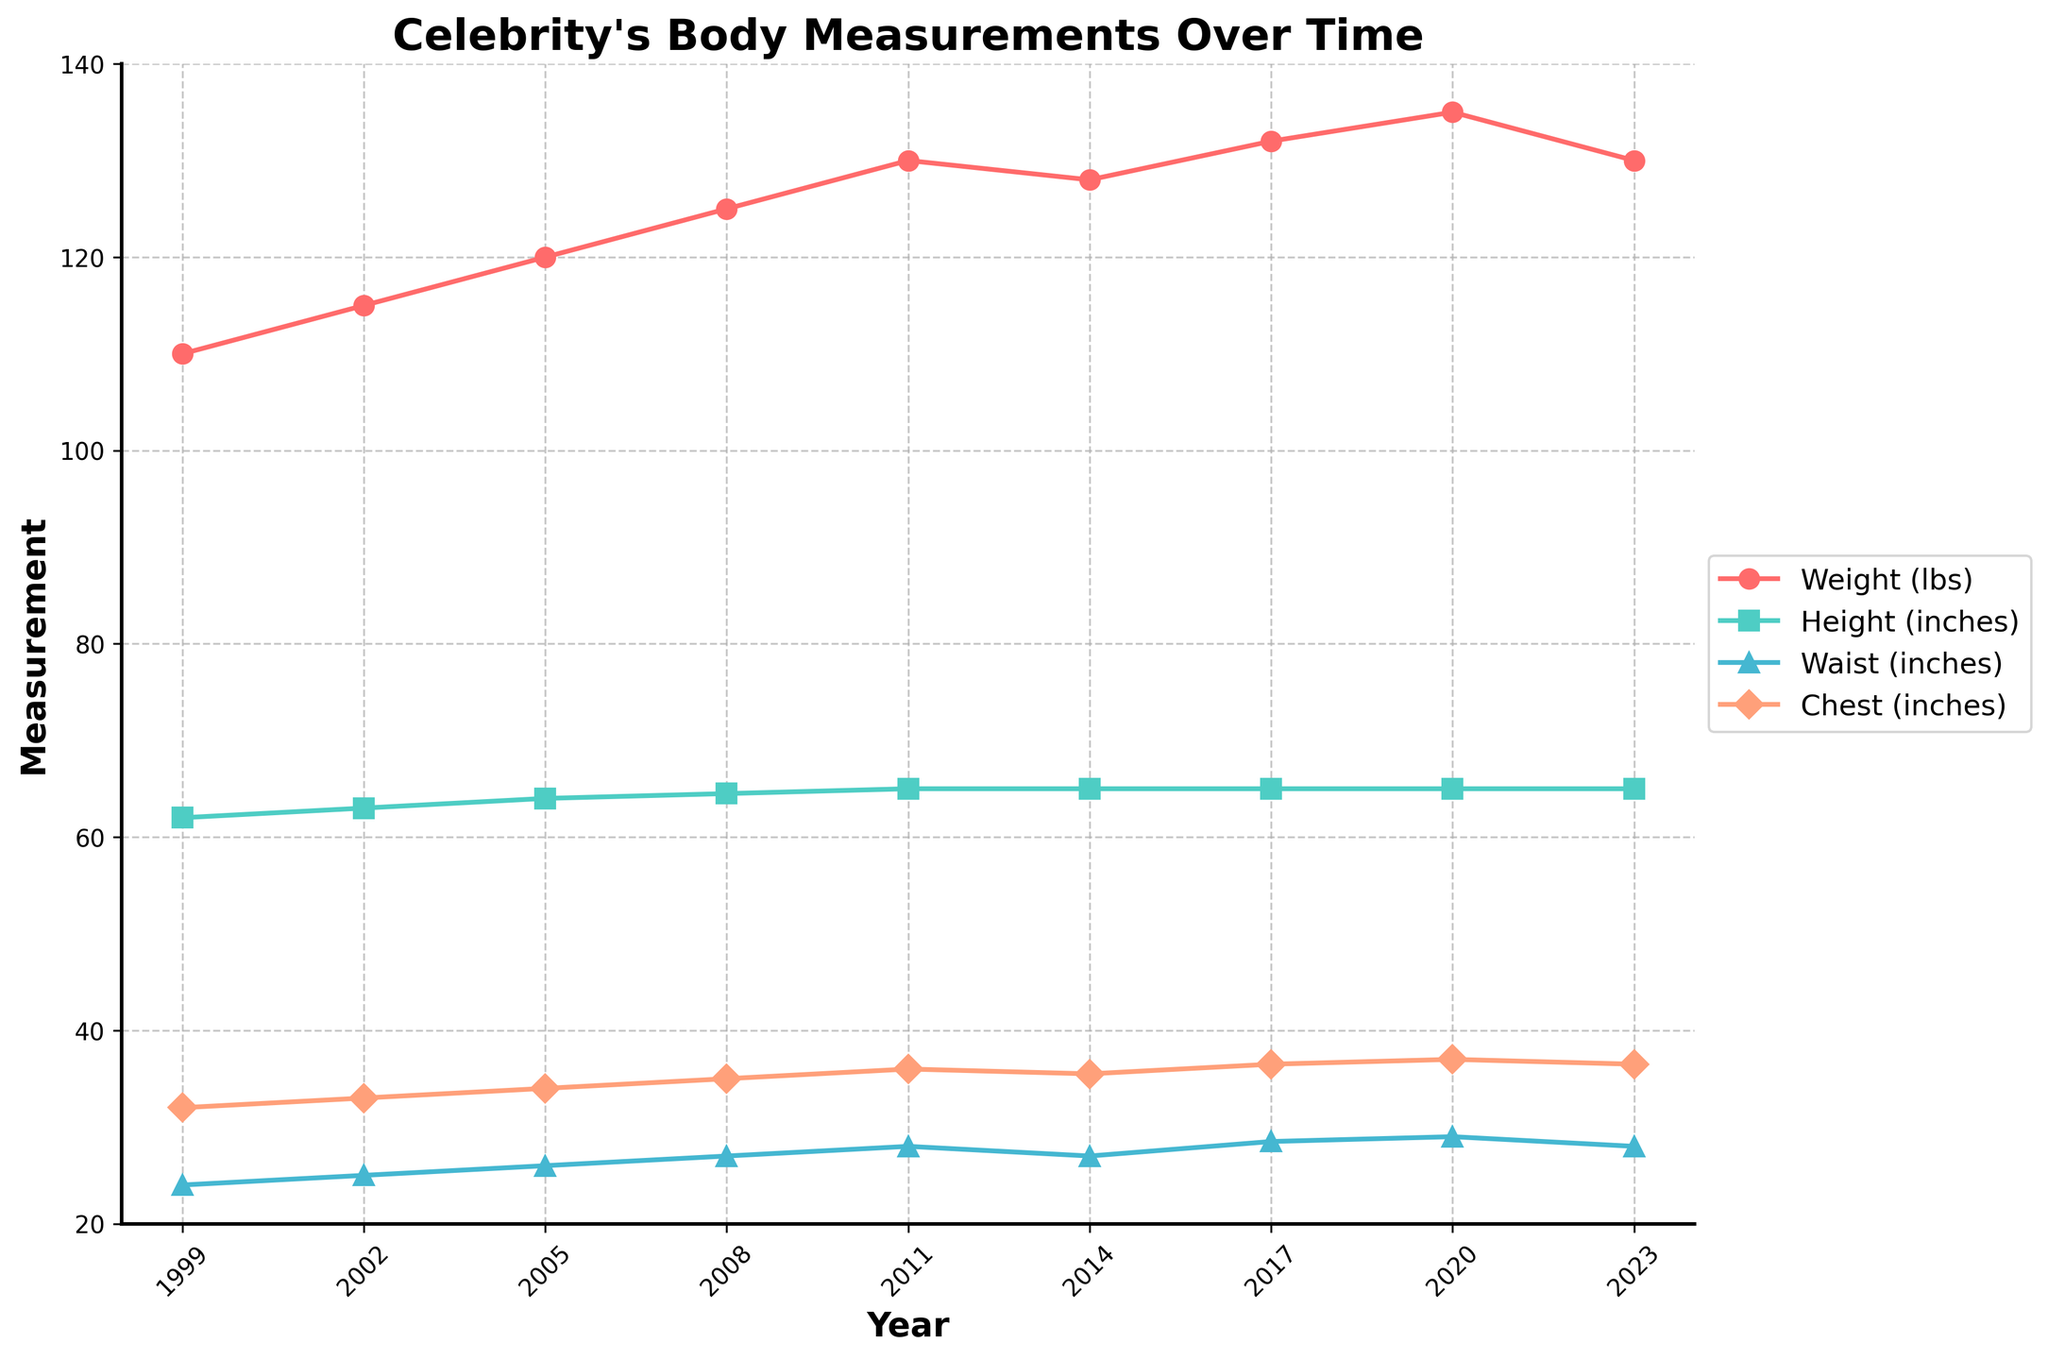What is the earliest year in the plot where weight data is available? The plot starts with measurements recorded in certain years. By looking at the x-axis, we can see the leftmost point where weight data is recorded.
Answer: 1999 In which year does the celebrity reach the highest weight recorded, and what is that weight? By examining the trajectory of the weight line (red), the highest point is at the topmost peak, where the weight is highest over the years. Cross-check this with the year on the x-axis.
Answer: 2020, 135 lbs How much did the celebrity's height change from 1999 to 2011? Look at the height line (green) and note the values in 1999 and 2011. Compute the difference between these two values.
Answer: 3 inches Which measurement saw the least change over the years? Compare the lines for weight, height, waist, and chest. The line that shows the smallest variance (i.e., flatter and more stable) over time represents the least change.
Answer: Height What is the average chest measurement over the entire period? Sum up all the chest measurements (inches) and divide by the total number of years measured (9).
Answer: 34.6 inches During which period did the celebrity's waist measurement increase the most, and by how much? Examine the waist line closely and identify the largest increase between two consecutive time points, then calculate the difference.
Answer: 2017 to 2020, 0.5 inches How many different peaks in the chest measurement can you identify in the plot? Visualize the chest (blue) line and count the distinct peaks where the measurement increases and then decreases.
Answer: 3 peaks Which measurement showed a decrease between 2020 and 2023? Look at the trend lines for all measurements between 2020 and 2023, and identify which one has declined from 2020 to 2023.
Answer: Weight By how much did the waist measurement increase between 1999 and 2020? Identify the waist measurement in 1999 and 2020 from the plot, then subtract the 1999 value from the 2020 value for the increase.
Answer: 5 inches At what year did the celebrity's weight first exceed 120 lbs? Find the point on the weight line (red) that exceeds 120 lbs for the first time and note the corresponding year on the x-axis.
Answer: 2005 